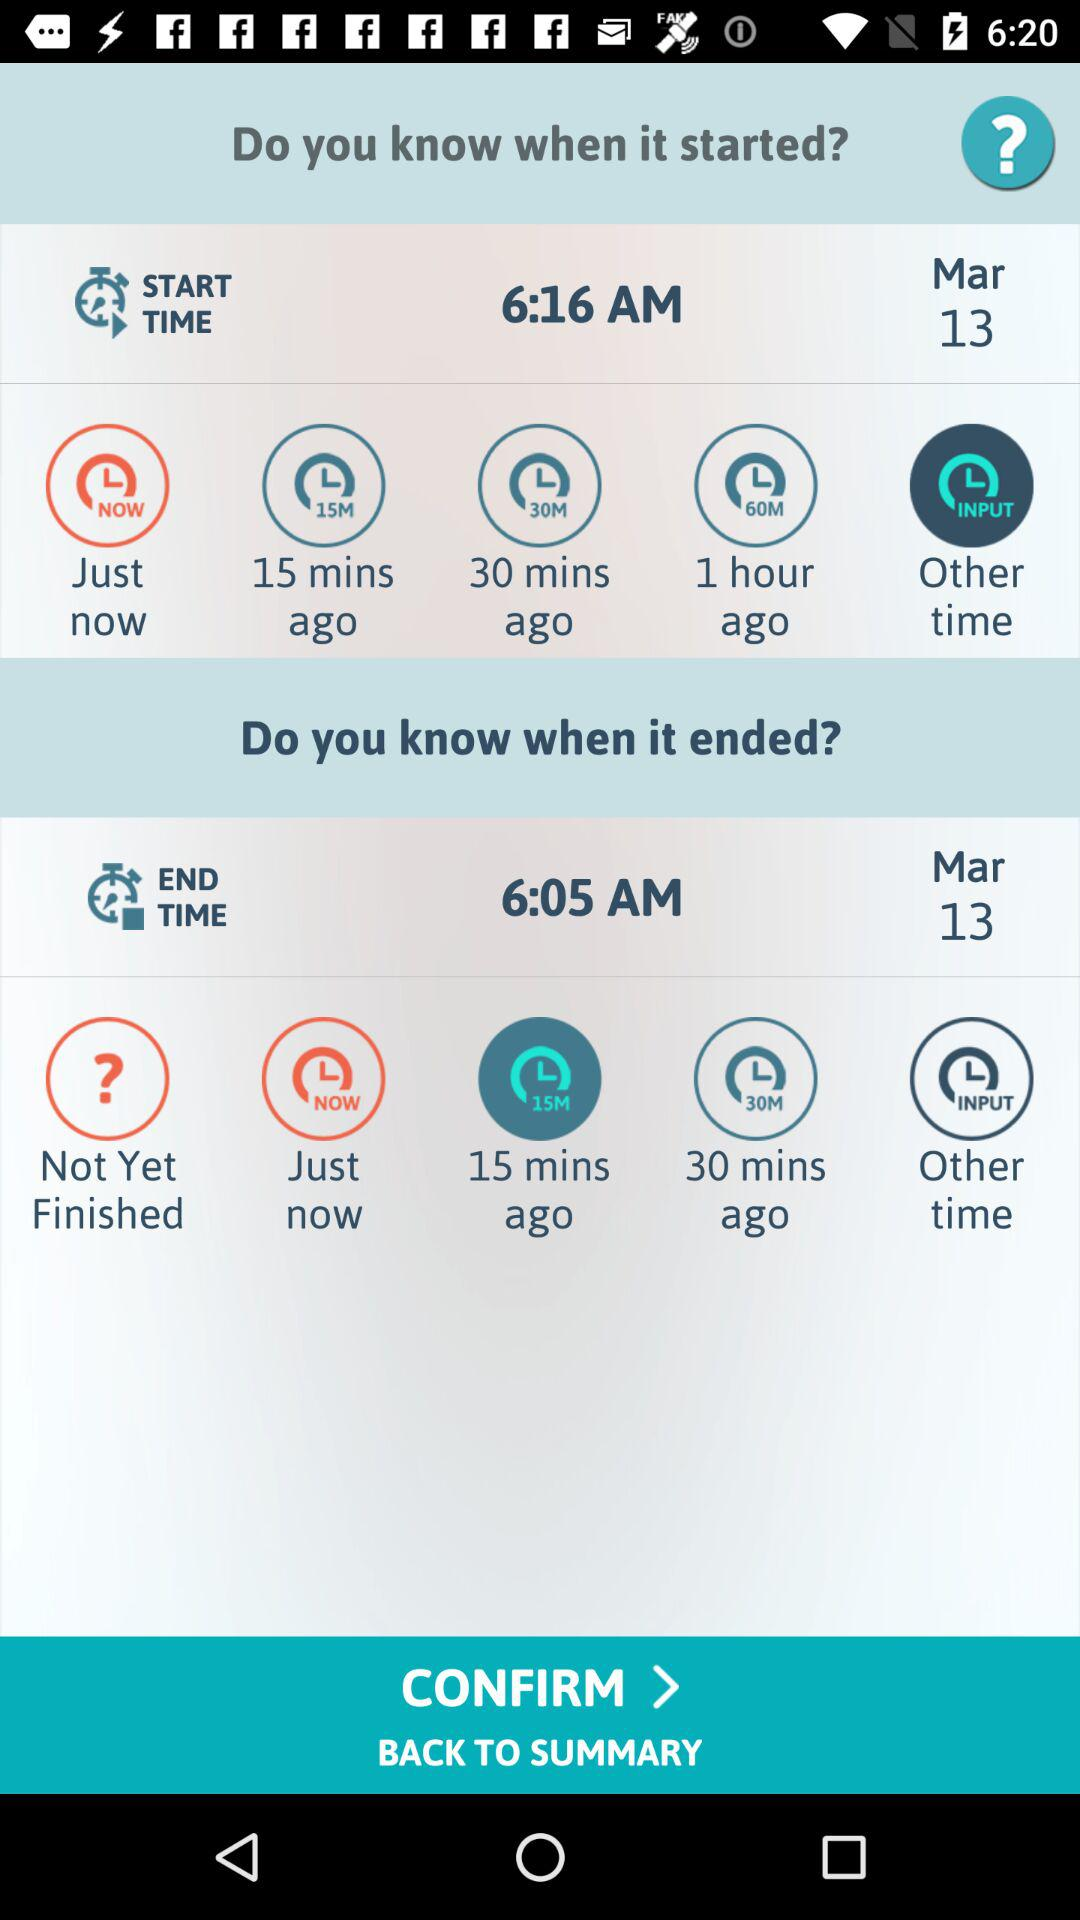In the started option, which button has been selected?
When the provided information is insufficient, respond with <no answer>. <no answer> 